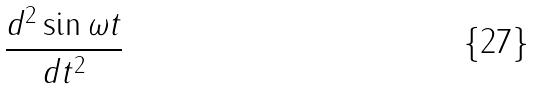<formula> <loc_0><loc_0><loc_500><loc_500>\frac { d ^ { 2 } \sin \omega t } { d t ^ { 2 } }</formula> 